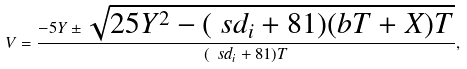<formula> <loc_0><loc_0><loc_500><loc_500>V = \frac { - 5 Y \pm \sqrt { 2 5 Y ^ { 2 } - ( \ s d _ { i } + 8 1 ) ( b T + X ) T } } { ( \ s d _ { i } + 8 1 ) T } ,</formula> 